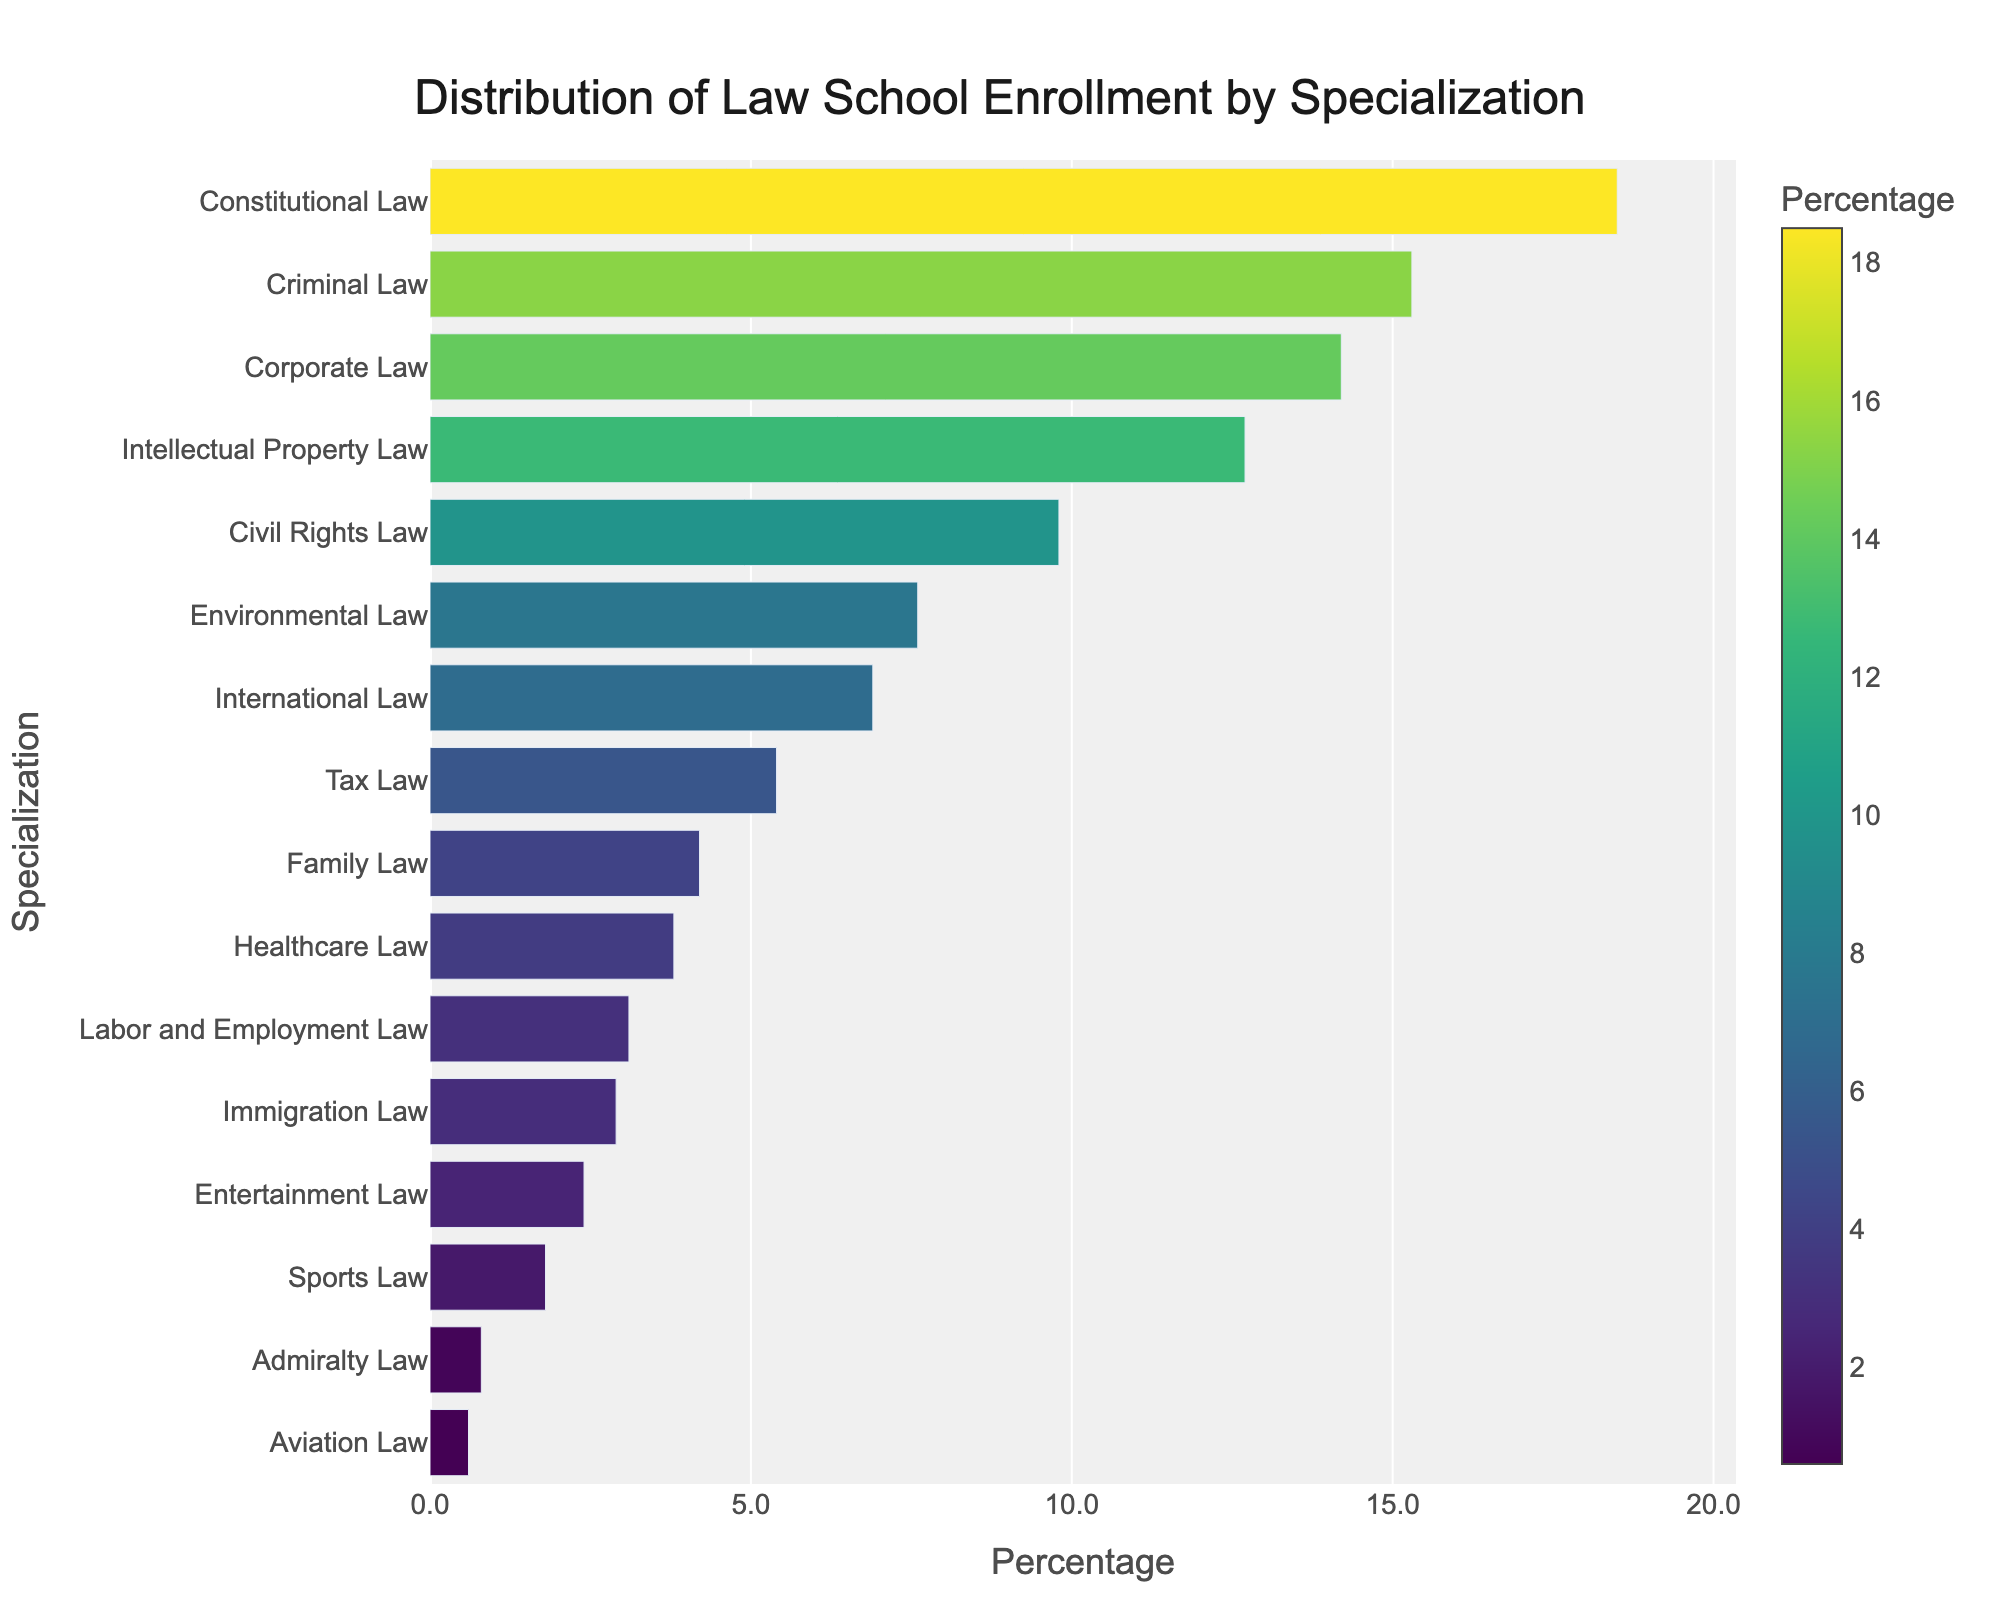What specialization has the highest enrollment percentage? The highest bar in the bar chart is for "Constitutional Law" with the highest percentage shown.
Answer: Constitutional Law What is the enrollment percentage of Corporate Law? The bar labeled "Corporate Law" reaches up to the 14.2% mark on the x-axis.
Answer: 14.2% How does the enrollment percentage of Criminal Law compare to Intellectual Property Law? By comparing the bars for "Criminal Law" and "Intellectual Property Law", it is clear that "Criminal Law" has a higher percentage (15.3%) compared to "Intellectual Property Law" (12.7%).
Answer: Criminal Law has a higher percentage Which specialization has the lowest enrollment percentage, and what is that percentage? The shortest bar in the bar chart corresponds to "Aviation Law," which reaches only up to 0.6% on the x-axis.
Answer: Aviation Law, 0.6% What is the total enrollment percentage for Civil Rights Law, Environmental Law, and International Law combined? Adding up the percentages for "Civil Rights Law" (9.8%), "Environmental Law" (7.6%), and "International Law" (6.9%) gives a total of 24.3%.
Answer: 24.3% How many specializations have an enrollment percentage lower than 5%? The bars for "Family Law" (4.2%), "Healthcare Law" (3.8%), "Labor and Employment Law" (3.1%), "Immigration Law" (2.9%), "Entertainment Law" (2.4%), "Sports Law" (1.8%), "Admiralty Law" (0.8%), and "Aviation Law" (0.6%) all fall under 5%. That's 8 specializations.
Answer: 8 Which specialization is most similar in enrollment percentage to Family Law? Comparing the bar heights, "Healthcare Law" (3.8%) is closest to "Family Law" (4.2%).
Answer: Healthcare Law What is the range of enrollment percentages in the data? The highest percentage is for "Constitutional Law" (18.5%) and the lowest is for "Aviation Law" (0.6%). Subtracting the lowest from the highest gives a range of 17.9%.
Answer: 17.9% Which specializations have enrollment percentages between 10% and 15%? The bars for "Corporate Law" (14.2%) and "Intellectual Property Law" (12.7%) fall within the range of 10% to 15%.
Answer: Corporate Law, Intellectual Property Law 